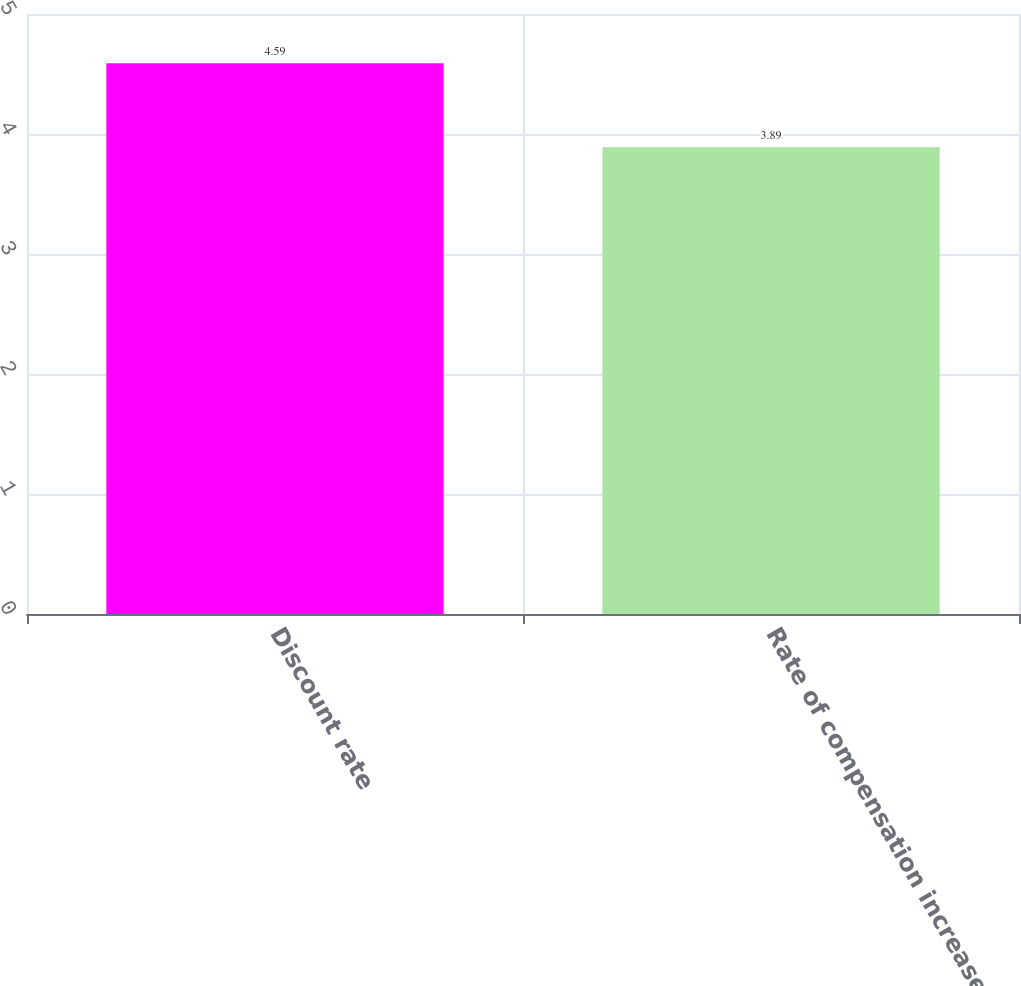Convert chart. <chart><loc_0><loc_0><loc_500><loc_500><bar_chart><fcel>Discount rate<fcel>Rate of compensation increase<nl><fcel>4.59<fcel>3.89<nl></chart> 